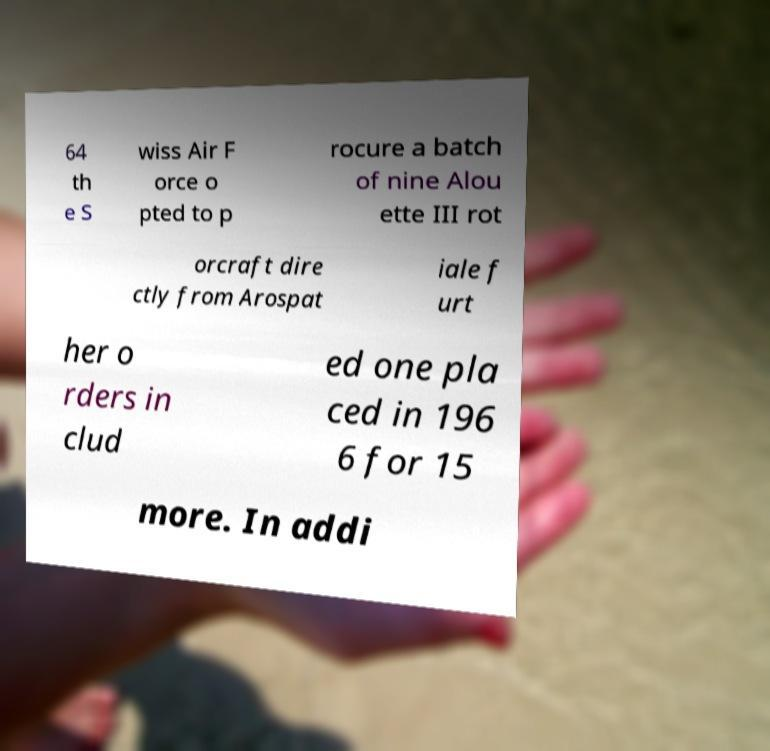Please identify and transcribe the text found in this image. 64 th e S wiss Air F orce o pted to p rocure a batch of nine Alou ette III rot orcraft dire ctly from Arospat iale f urt her o rders in clud ed one pla ced in 196 6 for 15 more. In addi 